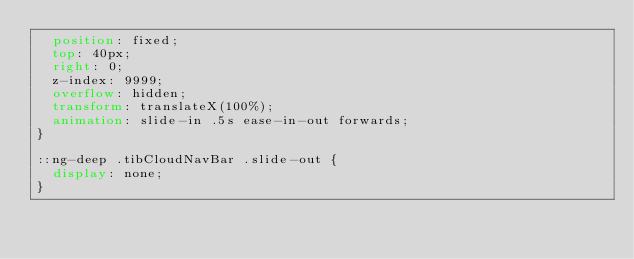Convert code to text. <code><loc_0><loc_0><loc_500><loc_500><_CSS_>  position: fixed;
  top: 40px;
  right: 0;
  z-index: 9999;
  overflow: hidden;
  transform: translateX(100%);
  animation: slide-in .5s ease-in-out forwards;
}

::ng-deep .tibCloudNavBar .slide-out {
  display: none;
}
</code> 